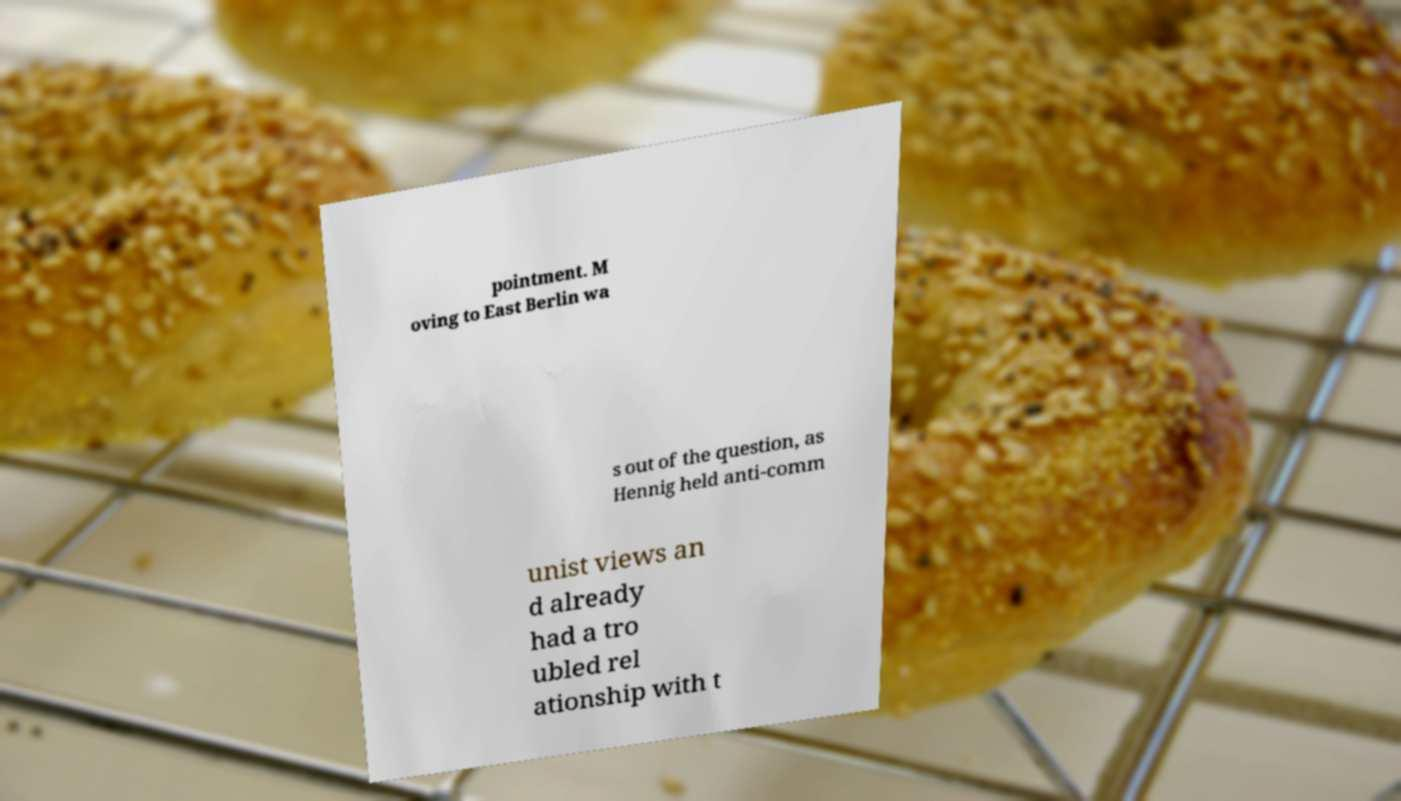Could you extract and type out the text from this image? pointment. M oving to East Berlin wa s out of the question, as Hennig held anti-comm unist views an d already had a tro ubled rel ationship with t 